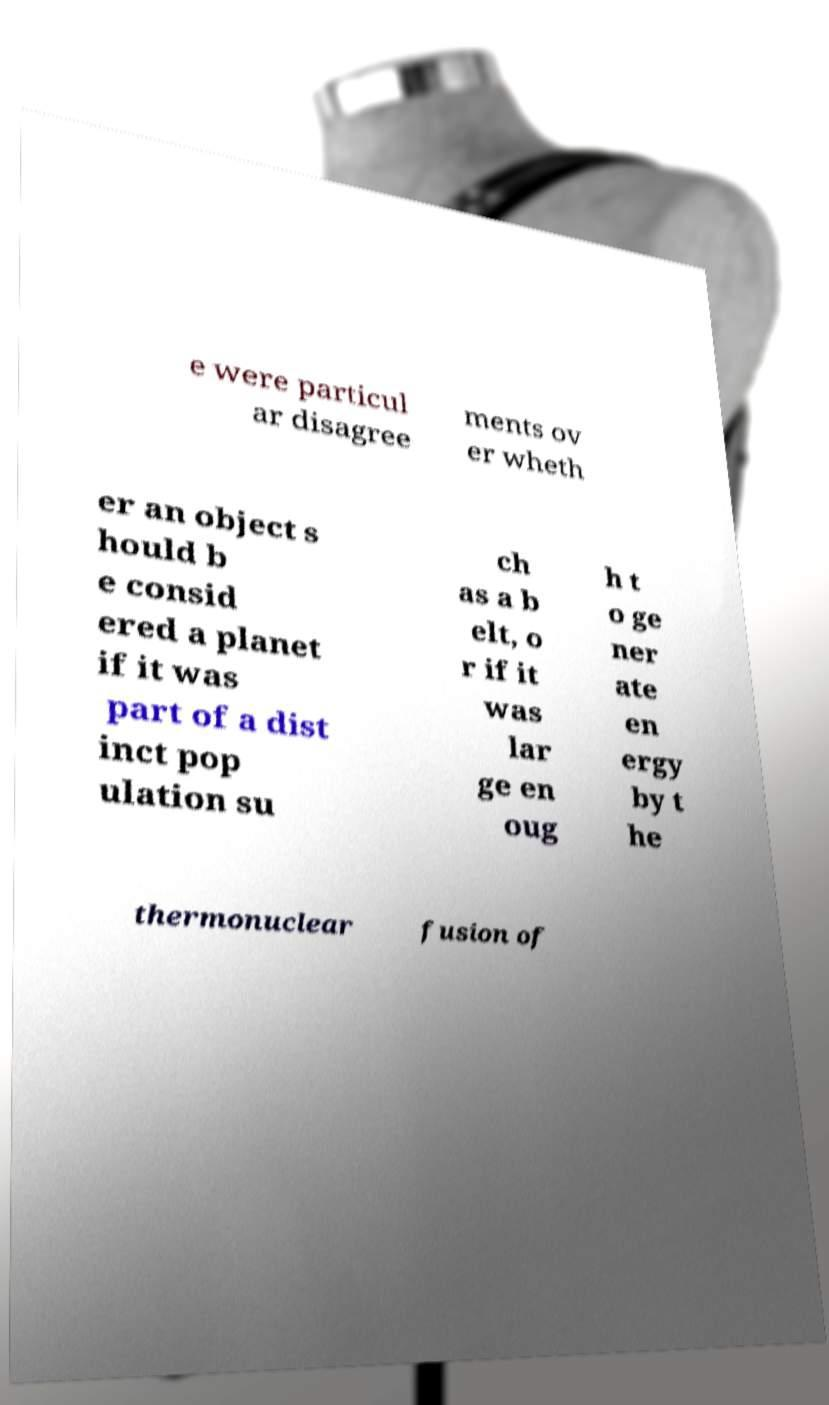Please identify and transcribe the text found in this image. e were particul ar disagree ments ov er wheth er an object s hould b e consid ered a planet if it was part of a dist inct pop ulation su ch as a b elt, o r if it was lar ge en oug h t o ge ner ate en ergy by t he thermonuclear fusion of 